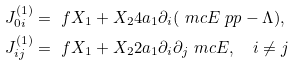<formula> <loc_0><loc_0><loc_500><loc_500>J ^ { ( 1 ) } _ { 0 i } & = \ f { X _ { 1 } + X _ { 2 } } { 4 a _ { 1 } } \partial _ { i } ( \ m c { E } \ p p - \Lambda ) , \\ J ^ { ( 1 ) } _ { i j } & = \ f { X _ { 1 } + X _ { 2 } } { 2 a _ { 1 } } \partial _ { i } \partial _ { j } \ m c { E } , \quad i \neq j</formula> 